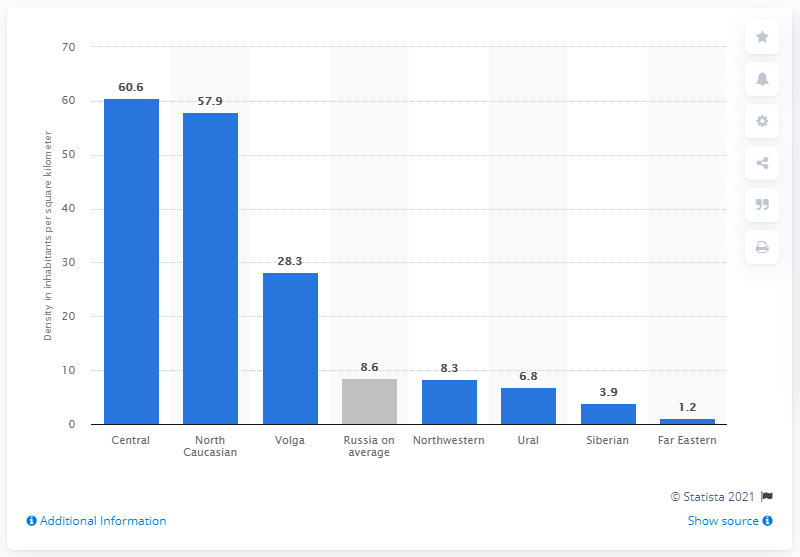Point out several critical features in this image. The population density in the Central federal district was approximately 60.6 people per square kilometer. 